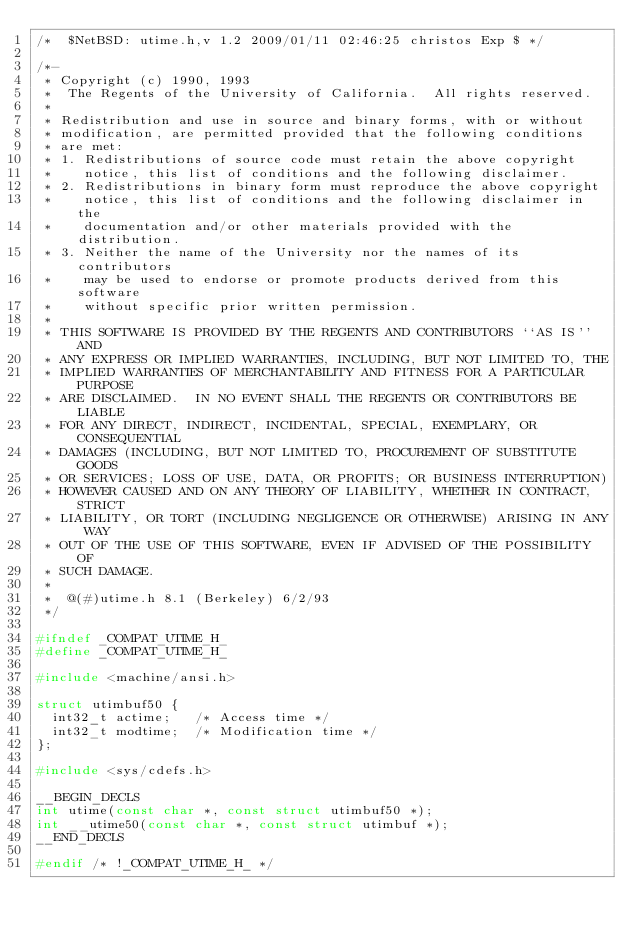<code> <loc_0><loc_0><loc_500><loc_500><_C_>/*	$NetBSD: utime.h,v 1.2 2009/01/11 02:46:25 christos Exp $	*/

/*-
 * Copyright (c) 1990, 1993
 *	The Regents of the University of California.  All rights reserved.
 *
 * Redistribution and use in source and binary forms, with or without
 * modification, are permitted provided that the following conditions
 * are met:
 * 1. Redistributions of source code must retain the above copyright
 *    notice, this list of conditions and the following disclaimer.
 * 2. Redistributions in binary form must reproduce the above copyright
 *    notice, this list of conditions and the following disclaimer in the
 *    documentation and/or other materials provided with the distribution.
 * 3. Neither the name of the University nor the names of its contributors
 *    may be used to endorse or promote products derived from this software
 *    without specific prior written permission.
 *
 * THIS SOFTWARE IS PROVIDED BY THE REGENTS AND CONTRIBUTORS ``AS IS'' AND
 * ANY EXPRESS OR IMPLIED WARRANTIES, INCLUDING, BUT NOT LIMITED TO, THE
 * IMPLIED WARRANTIES OF MERCHANTABILITY AND FITNESS FOR A PARTICULAR PURPOSE
 * ARE DISCLAIMED.  IN NO EVENT SHALL THE REGENTS OR CONTRIBUTORS BE LIABLE
 * FOR ANY DIRECT, INDIRECT, INCIDENTAL, SPECIAL, EXEMPLARY, OR CONSEQUENTIAL
 * DAMAGES (INCLUDING, BUT NOT LIMITED TO, PROCUREMENT OF SUBSTITUTE GOODS
 * OR SERVICES; LOSS OF USE, DATA, OR PROFITS; OR BUSINESS INTERRUPTION)
 * HOWEVER CAUSED AND ON ANY THEORY OF LIABILITY, WHETHER IN CONTRACT, STRICT
 * LIABILITY, OR TORT (INCLUDING NEGLIGENCE OR OTHERWISE) ARISING IN ANY WAY
 * OUT OF THE USE OF THIS SOFTWARE, EVEN IF ADVISED OF THE POSSIBILITY OF
 * SUCH DAMAGE.
 *
 *	@(#)utime.h	8.1 (Berkeley) 6/2/93
 */

#ifndef	_COMPAT_UTIME_H_
#define	_COMPAT_UTIME_H_

#include <machine/ansi.h>

struct utimbuf50 {
	int32_t actime;		/* Access time */
	int32_t modtime;	/* Modification time */
};

#include <sys/cdefs.h>

__BEGIN_DECLS
int utime(const char *, const struct utimbuf50 *);
int __utime50(const char *, const struct utimbuf *);
__END_DECLS

#endif /* !_COMPAT_UTIME_H_ */
</code> 